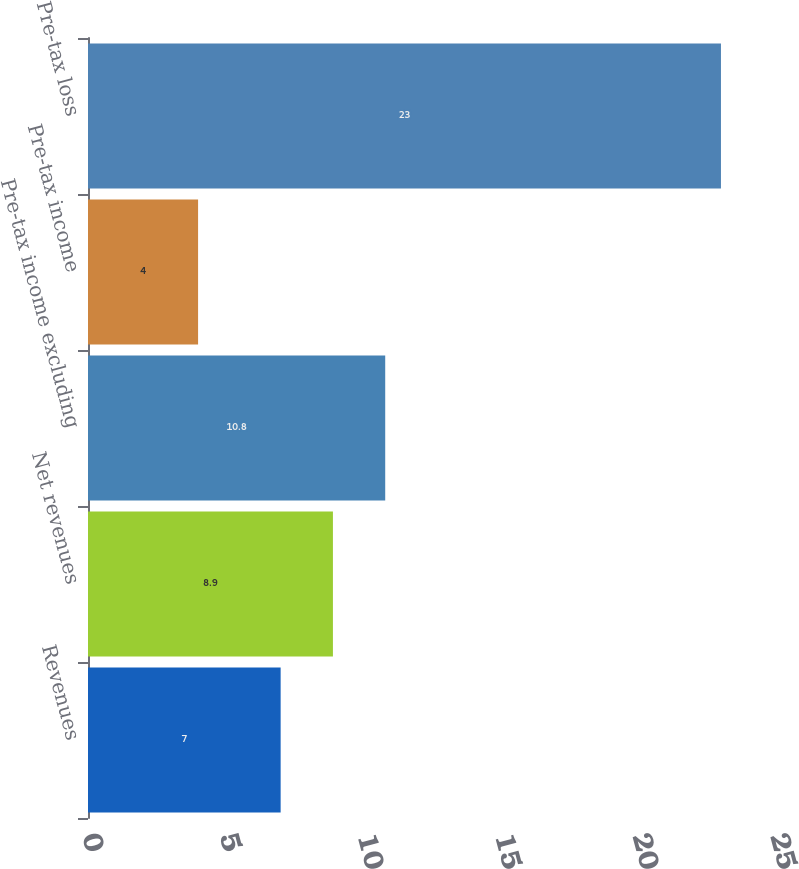<chart> <loc_0><loc_0><loc_500><loc_500><bar_chart><fcel>Revenues<fcel>Net revenues<fcel>Pre-tax income excluding<fcel>Pre-tax income<fcel>Pre-tax loss<nl><fcel>7<fcel>8.9<fcel>10.8<fcel>4<fcel>23<nl></chart> 